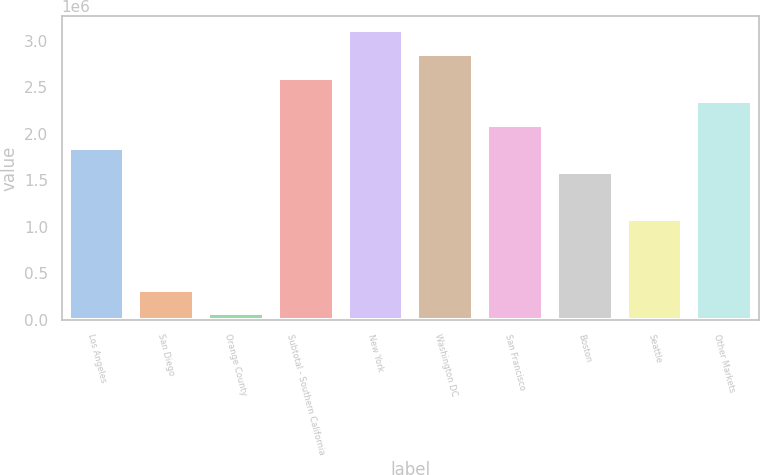Convert chart. <chart><loc_0><loc_0><loc_500><loc_500><bar_chart><fcel>Los Angeles<fcel>San Diego<fcel>Orange County<fcel>Subtotal - Southern California<fcel>New York<fcel>Washington DC<fcel>San Francisco<fcel>Boston<fcel>Seattle<fcel>Other Markets<nl><fcel>1.84515e+06<fcel>324827<fcel>71440<fcel>2.60531e+06<fcel>3.11209e+06<fcel>2.8587e+06<fcel>2.09854e+06<fcel>1.59176e+06<fcel>1.08499e+06<fcel>2.35192e+06<nl></chart> 